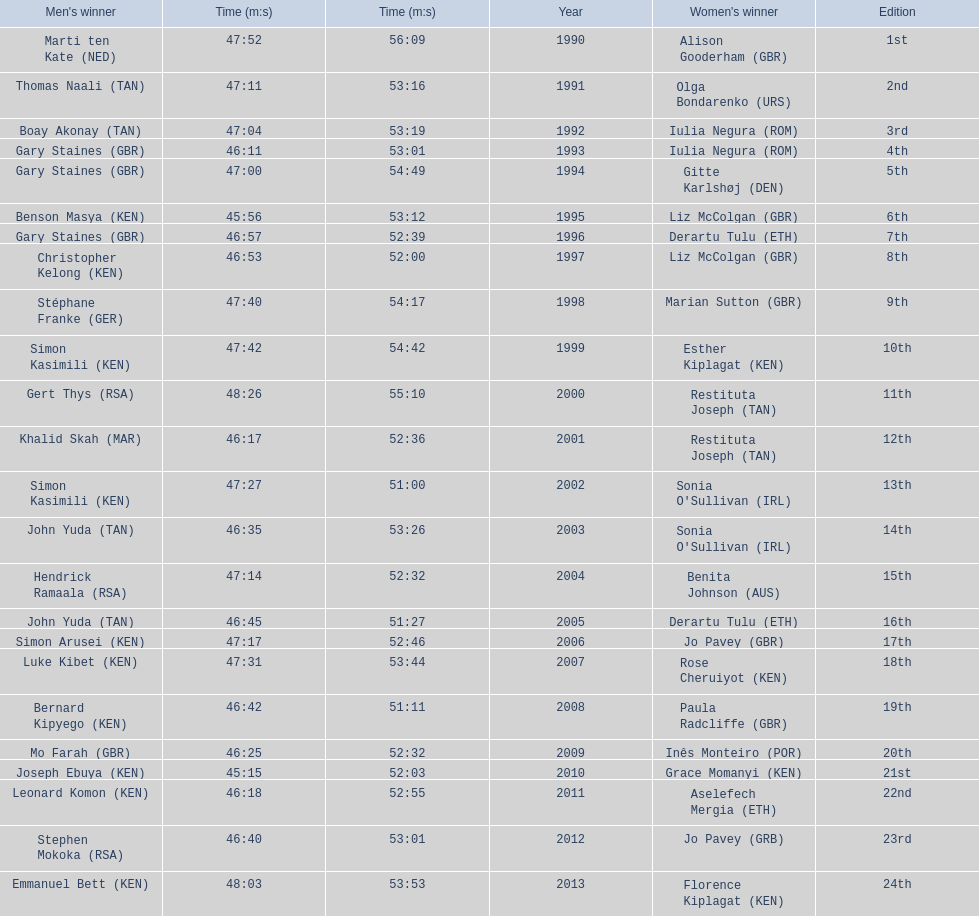What are the names of each male winner? Marti ten Kate (NED), Thomas Naali (TAN), Boay Akonay (TAN), Gary Staines (GBR), Gary Staines (GBR), Benson Masya (KEN), Gary Staines (GBR), Christopher Kelong (KEN), Stéphane Franke (GER), Simon Kasimili (KEN), Gert Thys (RSA), Khalid Skah (MAR), Simon Kasimili (KEN), John Yuda (TAN), Hendrick Ramaala (RSA), John Yuda (TAN), Simon Arusei (KEN), Luke Kibet (KEN), Bernard Kipyego (KEN), Mo Farah (GBR), Joseph Ebuya (KEN), Leonard Komon (KEN), Stephen Mokoka (RSA), Emmanuel Bett (KEN). When did they race? 1990, 1991, 1992, 1993, 1994, 1995, 1996, 1997, 1998, 1999, 2000, 2001, 2002, 2003, 2004, 2005, 2006, 2007, 2008, 2009, 2010, 2011, 2012, 2013. And what were their times? 47:52, 47:11, 47:04, 46:11, 47:00, 45:56, 46:57, 46:53, 47:40, 47:42, 48:26, 46:17, 47:27, 46:35, 47:14, 46:45, 47:17, 47:31, 46:42, 46:25, 45:15, 46:18, 46:40, 48:03. Of those times, which athlete had the fastest time? Joseph Ebuya (KEN). 